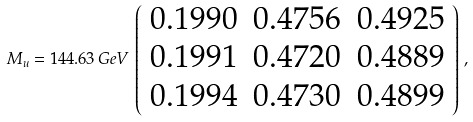<formula> <loc_0><loc_0><loc_500><loc_500>M _ { u } = 1 4 4 . 6 3 \, G e V \, \left ( \begin{array} { c c c } 0 . 1 9 9 0 & 0 . 4 7 5 6 & 0 . 4 9 2 5 \\ 0 . 1 9 9 1 & 0 . 4 7 2 0 & 0 . 4 8 8 9 \\ 0 . 1 9 9 4 & 0 . 4 7 3 0 & 0 . 4 8 9 9 \end{array} \right ) \, ,</formula> 